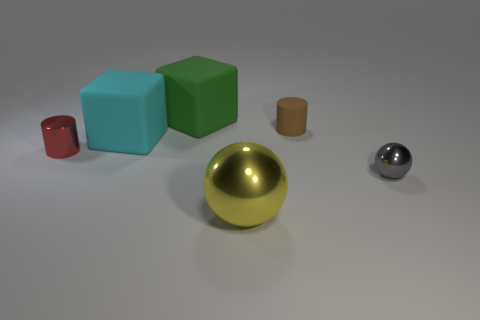Is the color of the big shiny sphere the same as the tiny metallic ball?
Give a very brief answer. No. There is a gray object that is the same size as the red metal cylinder; what shape is it?
Your answer should be compact. Sphere. Are there any tiny gray shiny spheres in front of the rubber cylinder?
Provide a succinct answer. Yes. There is a cylinder that is in front of the tiny brown rubber cylinder; is there a gray object right of it?
Your answer should be compact. Yes. Are there fewer cyan rubber things on the right side of the tiny matte cylinder than red metal cylinders that are behind the tiny sphere?
Your response must be concise. Yes. Is there any other thing that is the same size as the green rubber cube?
Offer a terse response. Yes. There is a tiny brown object; what shape is it?
Offer a very short reply. Cylinder. There is a cylinder that is right of the red cylinder; what is it made of?
Make the answer very short. Rubber. There is a cube in front of the tiny cylinder on the right side of the rubber cube in front of the small brown cylinder; how big is it?
Give a very brief answer. Large. Are the big thing that is in front of the tiny gray object and the thing that is behind the tiny brown cylinder made of the same material?
Ensure brevity in your answer.  No. 